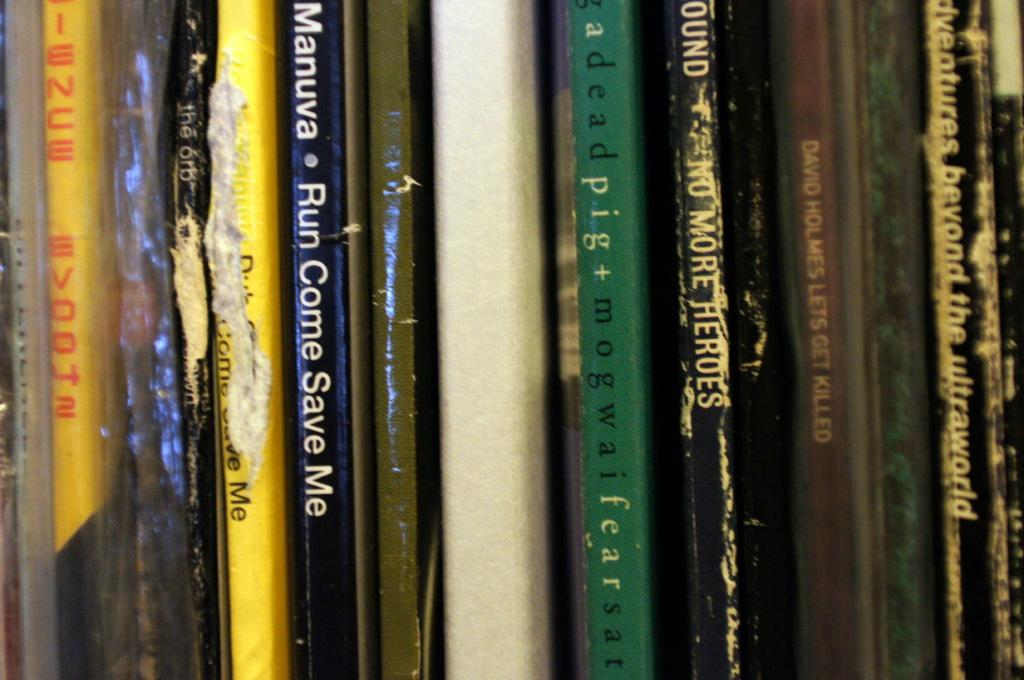Provide a one-sentence caption for the provided image. An assortment of books stacked upright vertically with one titled Run Come Save Me. 